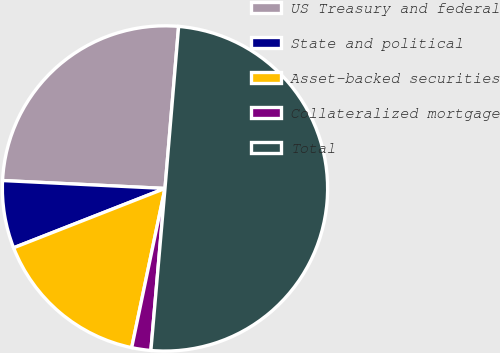Convert chart to OTSL. <chart><loc_0><loc_0><loc_500><loc_500><pie_chart><fcel>US Treasury and federal<fcel>State and political<fcel>Asset-backed securities<fcel>Collateralized mortgage<fcel>Total<nl><fcel>25.56%<fcel>6.72%<fcel>15.77%<fcel>1.9%<fcel>50.04%<nl></chart> 